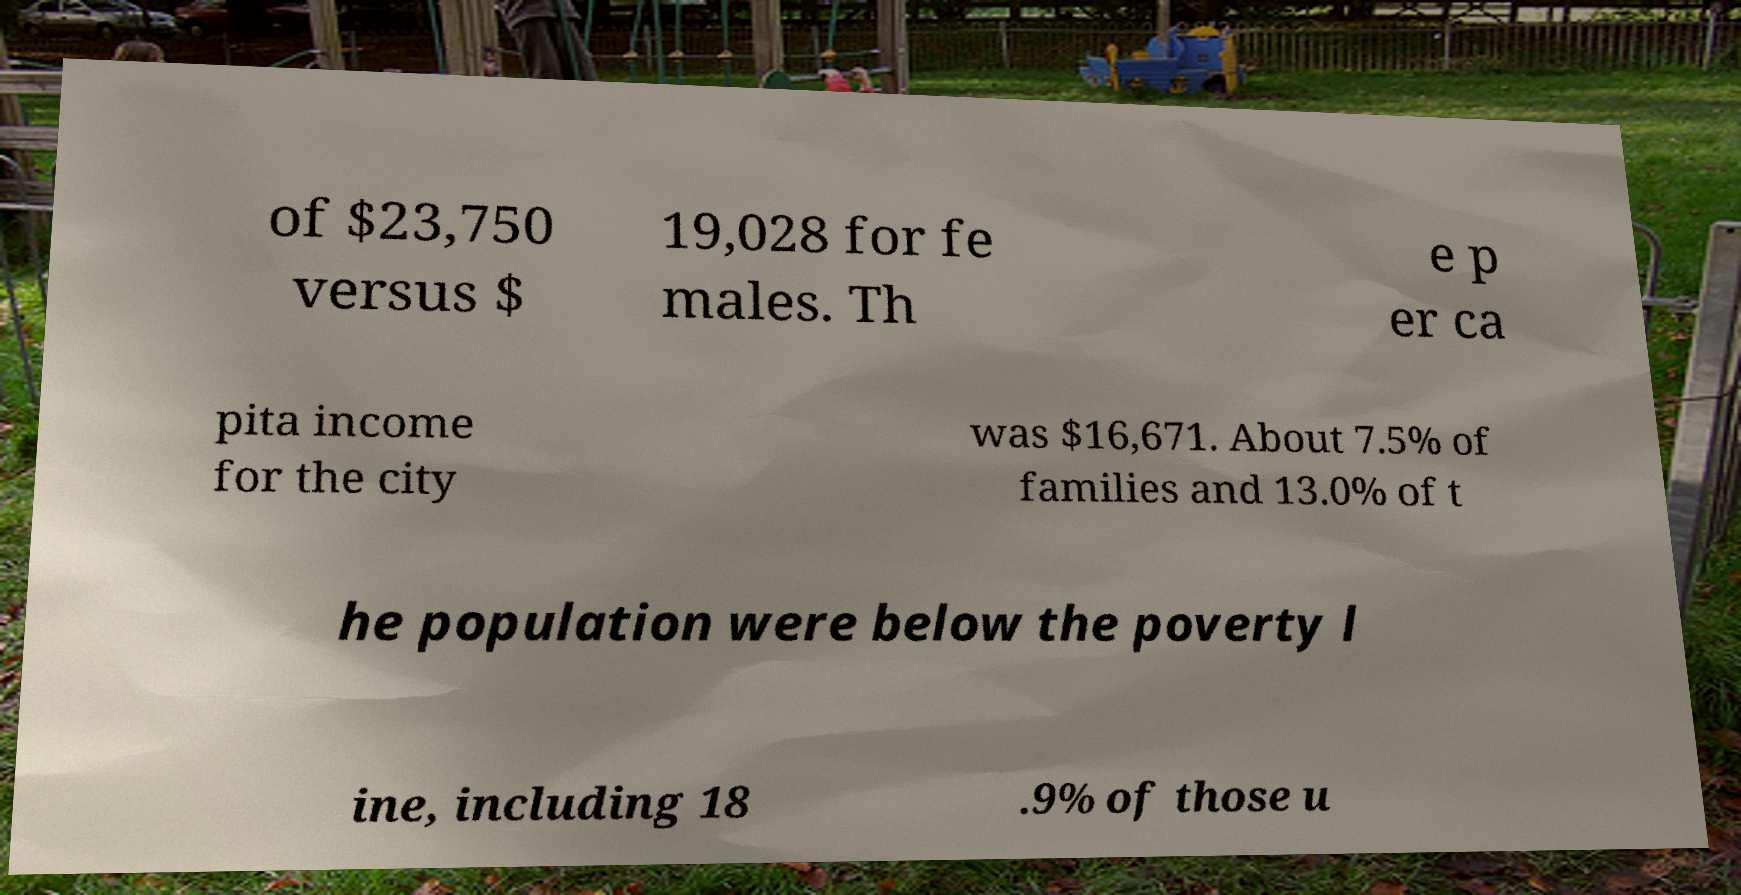What messages or text are displayed in this image? I need them in a readable, typed format. of $23,750 versus $ 19,028 for fe males. Th e p er ca pita income for the city was $16,671. About 7.5% of families and 13.0% of t he population were below the poverty l ine, including 18 .9% of those u 